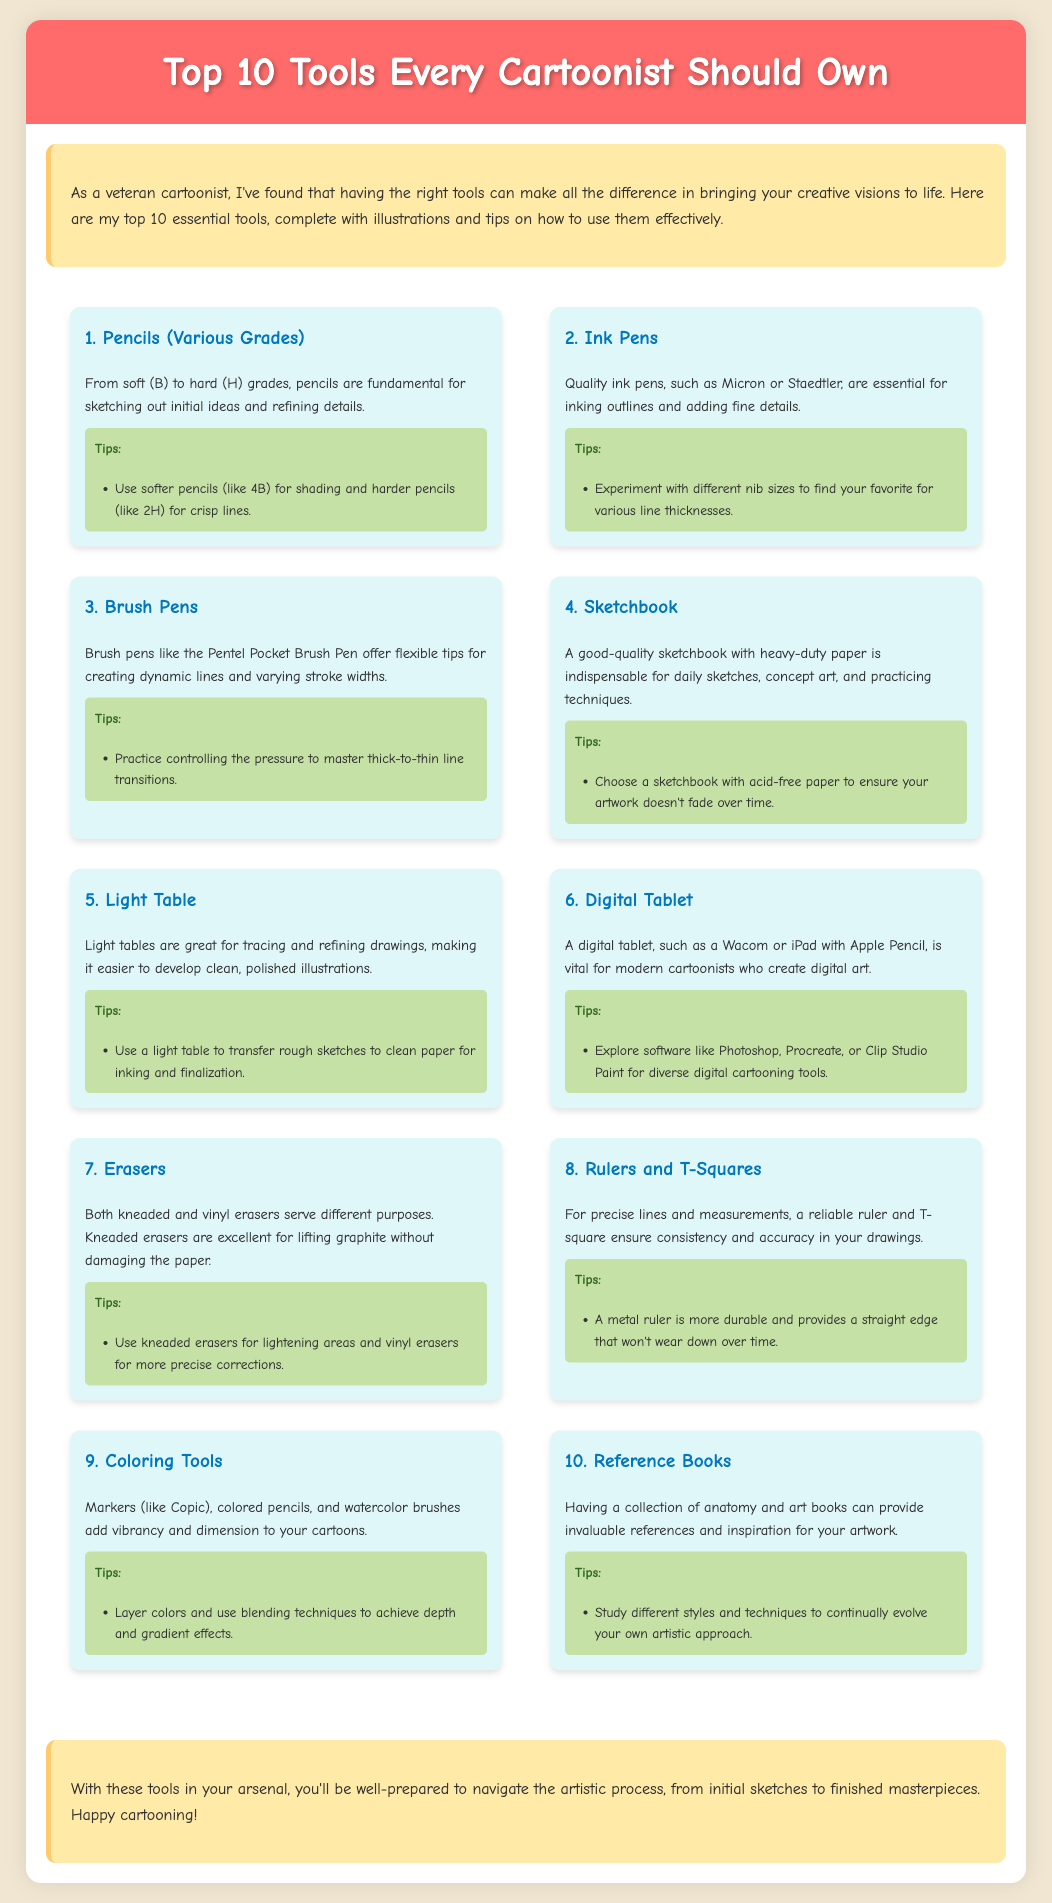what is the first tool listed? The first tool in the list is presented at the top of the infographic.
Answer: Pencils (Various Grades) how many tools are mentioned in total? The document highlights a complete set of tools that are numbered from 1 to 10.
Answer: 10 what type of eraser is mentioned as good for lifting graphite? The description discusses different types of erasers and identifies which is best for a specific function.
Answer: Kneaded erasers which digital tablet brand is mentioned? The document specifically mentions a brand of digital tablet that is popular among cartoonists.
Answer: Wacom what is recommended for achieving depth in coloring? The tips for coloring tools emphasize a specific technique for enhancing the artwork's appearance.
Answer: Blending techniques which tools are suggested for precise lines? This question asks for a specific pair of tools that ensure accuracy in drawings as noted in the tool descriptions.
Answer: Rulers and T-Squares what type of sketchbook should be chosen according to the tips? The tips provide a recommendation on paper quality for a type of sketchbook.
Answer: Acid-free paper who is likely the intended audience for this document? The introduction defines the target readers by calling them "veteran cartoonists."
Answer: Cartoonists which tool is associated with tracing and refining drawings? The document specifically states a tool utilized in the process of enhancing illustrations.
Answer: Light Table 